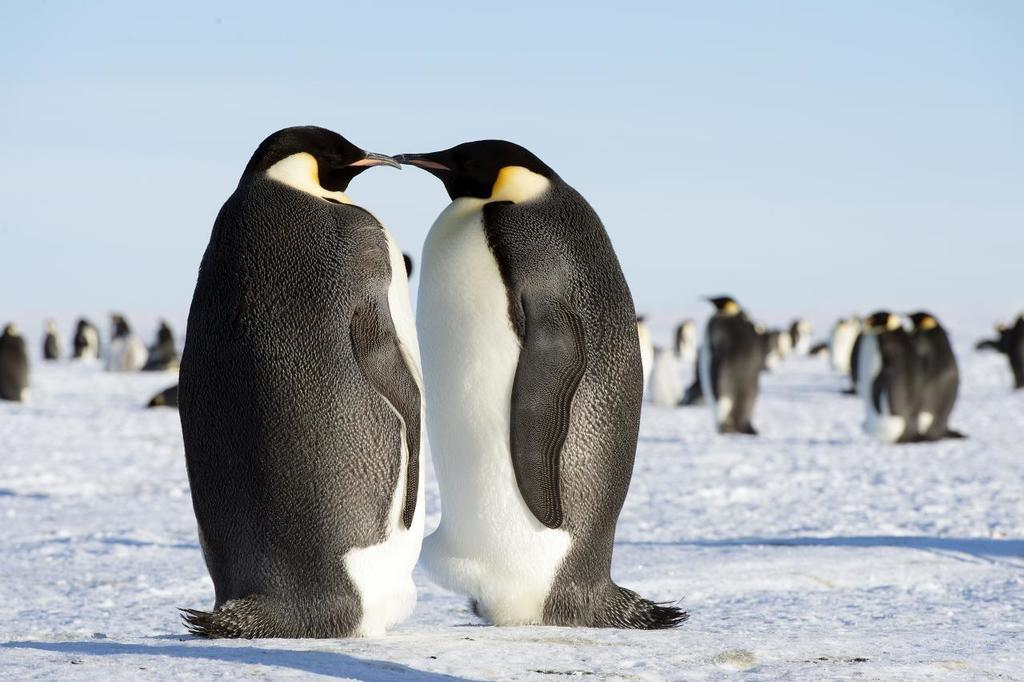What animals are present in the image? There are two penguins in the image. What is the surface on which the penguins are standing? The penguins are on the snow. How are the penguins positioned in relation to each other? The penguins are facing each other. What else can be seen in the background of the image? There are other penguins visible in the background of the image, and the sky is also visible. What is the condition of the penguins' teeth in the image? Penguins do not have teeth, so there is no condition to describe. What season is depicted in the image? The image does not provide any specific information about the season, but the presence of snow suggests it could be winter. 